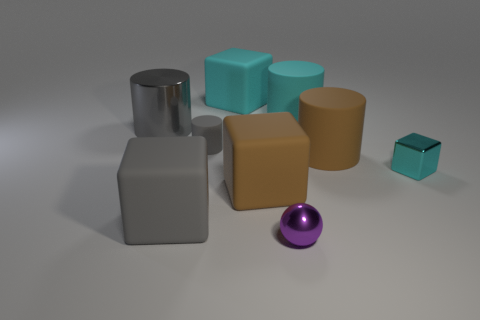Subtract all gray cubes. Subtract all purple cylinders. How many cubes are left? 3 Subtract all cylinders. How many objects are left? 5 Add 2 cubes. How many cubes exist? 6 Subtract 0 red balls. How many objects are left? 9 Subtract all large metal cylinders. Subtract all tiny metallic balls. How many objects are left? 7 Add 6 purple balls. How many purple balls are left? 7 